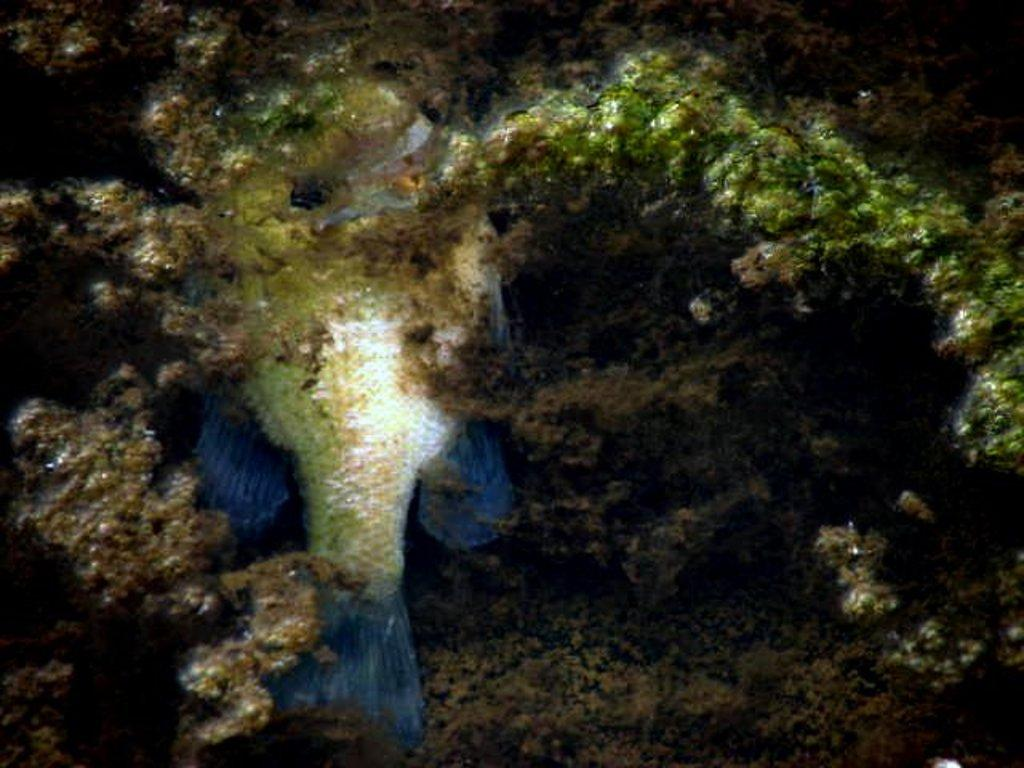What type of animals can be seen in the image? There are fish in the image. What other elements can be seen in the image besides the fish? There are aquatic plants in the image. What type of comb can be seen in the image? There is no comb present in the image; it features fish and aquatic plants. What type of leather material can be seen in the image? There is no leather material present in the image; it features fish and aquatic plants. 